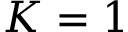<formula> <loc_0><loc_0><loc_500><loc_500>K = 1</formula> 